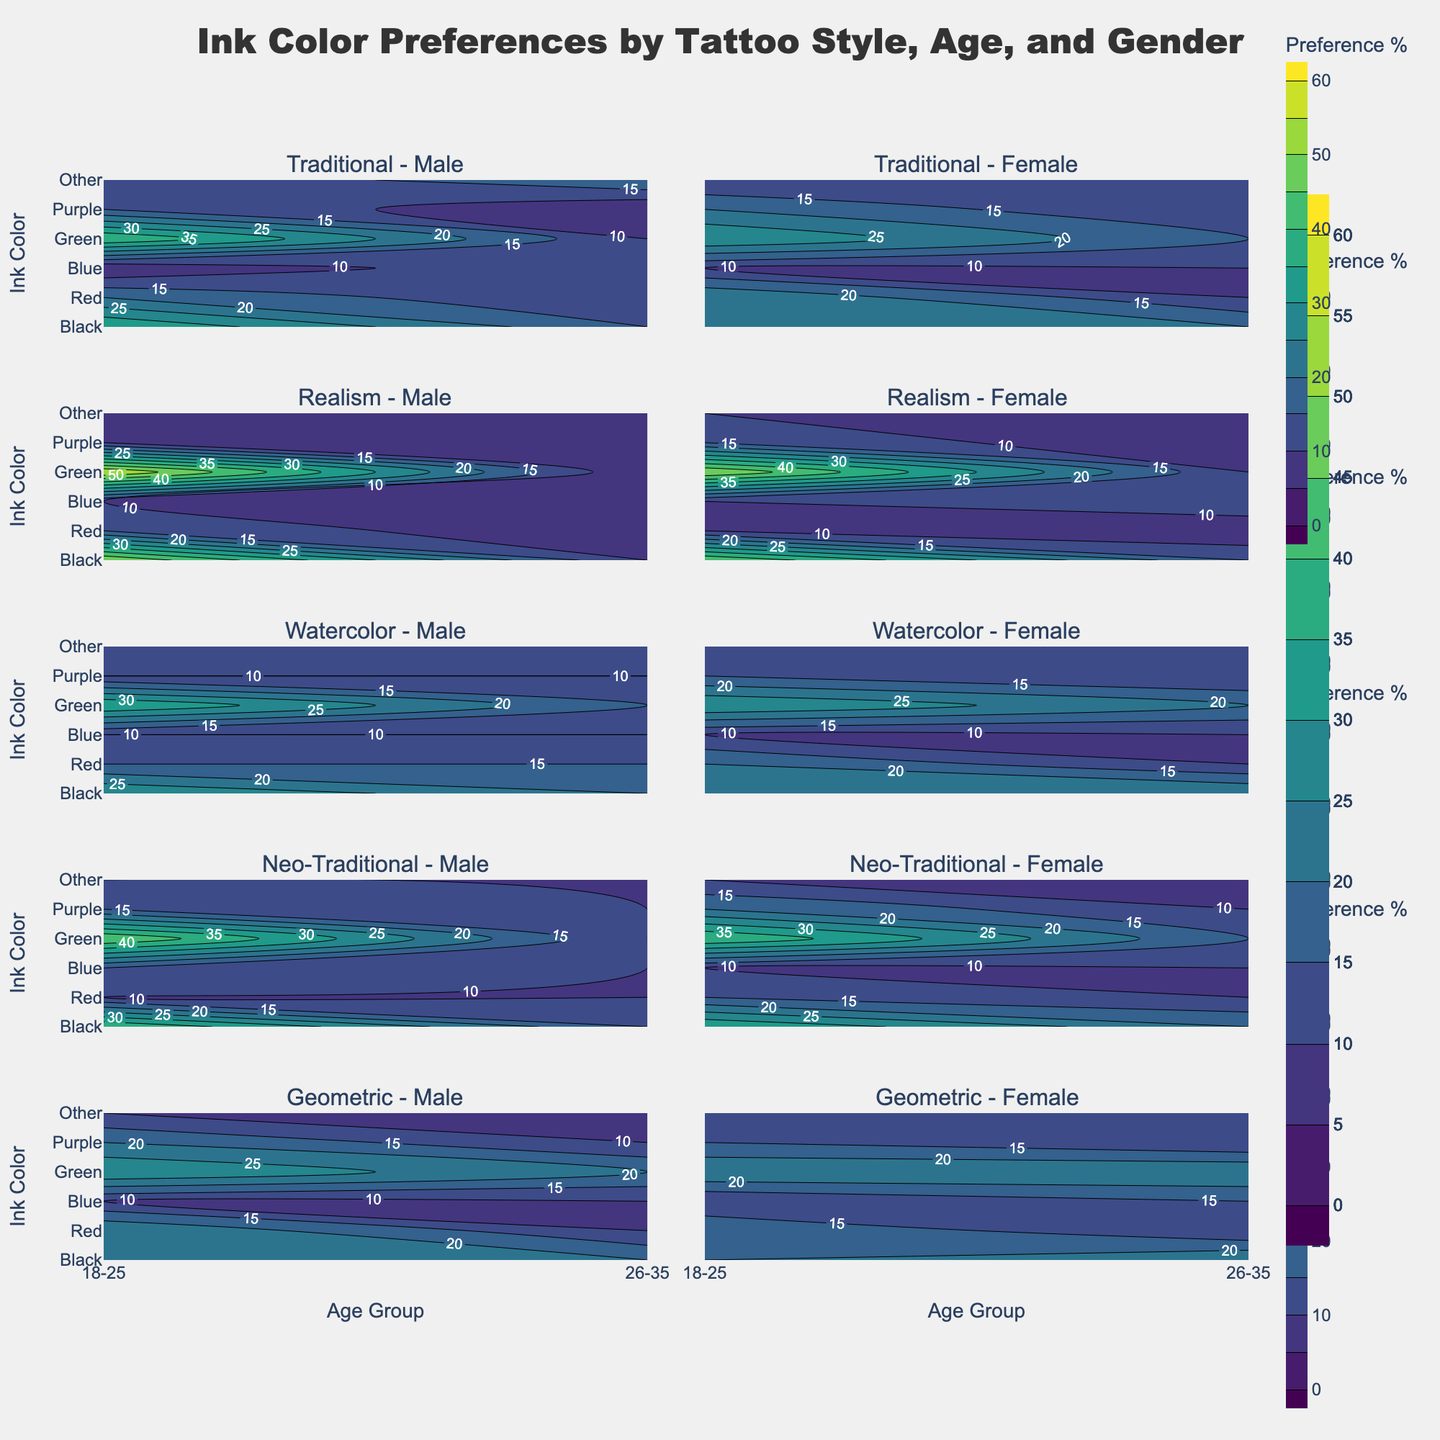Does the figure show a preference for a certain ink color across all tattoo styles for both genders? To determine this, we need to find any common trend across all the subplots. The "Black" ink typically has the highest preference across all ages and styles. This can be observed as the darkest or highest contour level in most subplots.
Answer: Yes, Black Which age group of females prefers Red ink the most across all styles? We need to find the highest contour level for "Red" ink in all the female subplots, distinguished by age group. The 18-25 age group for female Watercolor and Geometric styles show the highest preference for Red.
Answer: 18-25 Between the age groups 18–25 and 26–35, which age group shows a higher preference for Blue ink in Realism style for males? We compare the contour levels for "Blue" ink in Realism style for males across the two age groups. The 18-25 age group shows a higher level compared to the 26-35 age group.
Answer: 18-25 Is there a noticeable difference in the preference for Purple ink between males and females in the Traditional style? We compare the contour levels of "Purple" ink in Traditional style subplots for both males and females. Both genders have similar lower levels of preference for Purple ink, with slight variations.
Answer: No noticeable difference Which gender shows a higher preference for Green ink in Neo-Traditional style? Check the contour levels for "Green" ink in Neo-Traditional style for both males and females. The levels are quite similar, but males slightly prefer Green more.
Answer: Males In the Watercolor style, how does the preference for "Other" ink color compare between the two age groups for females? Compare the contour levels for "Other" ink in Watercolor style for females across the 18-25 and 26-35 age groups. The 26-35 age group shows a slightly higher preference.
Answer: Higher in 26-35 Which tattoo style has the least preference for Blue ink among males aged 26-35? Compare the contour levels for "Blue" ink in the male aged 26-35 subplots across all styles. The lowest contour level for Blue ink is found in the Watercolor style.
Answer: Watercolor What is the general trend for the preference of Red ink across all age groups in the Geometric style for females? Observe the contour levels for "Red" ink in the Geometric style for females across age groups. Both age groups show a strong preference for Red ink, with slightly higher levels in 18-25.
Answer: Strong preference in all age groups, higher in 18-25 